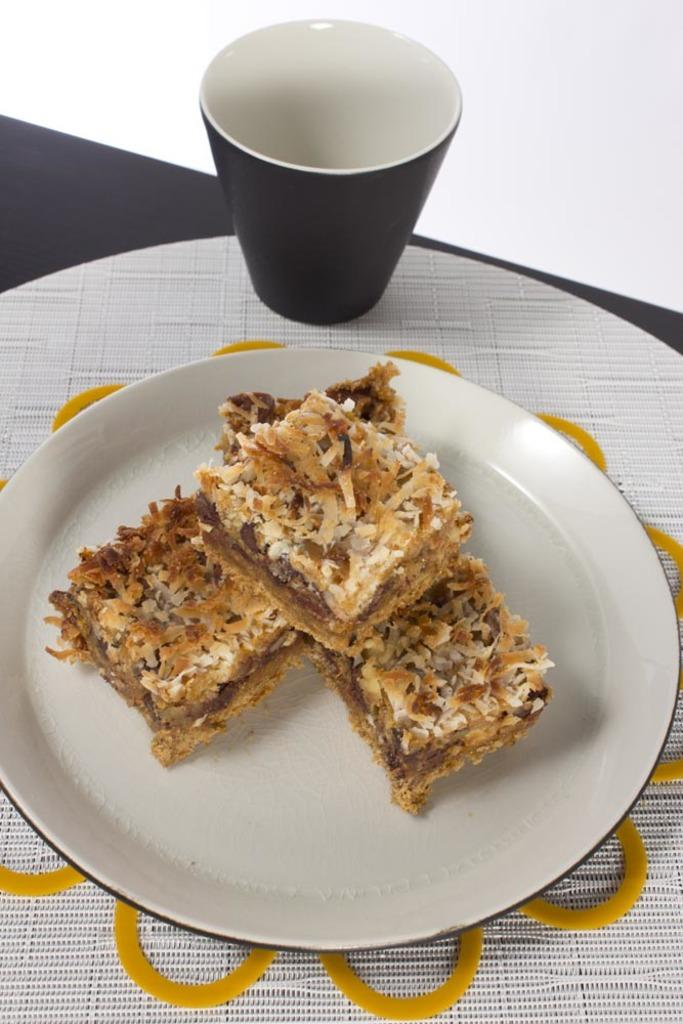What is on the plate that is visible in the image? There is food on a plate in the image. Where is the plate located in the image? The plate is placed on a table in the image. What else can be seen on the table in the image? There is a glass on the table in the image. Can you tell me how many people are in the group, walking on the sidewalk, and helping in the image? There is no group, sidewalk, or helping activity depicted in the image; it only shows a plate of food on a table with a glass. 